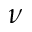Convert formula to latex. <formula><loc_0><loc_0><loc_500><loc_500>\nu</formula> 